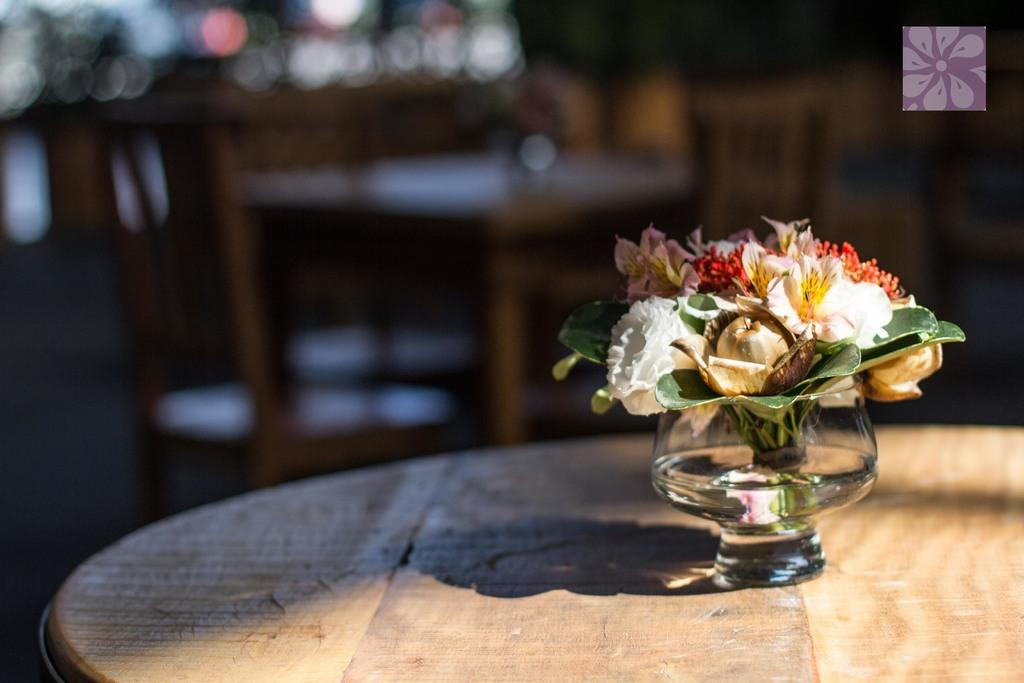What is the main object in the image? There is a table in the image. What is placed on the table? There are flowers on the table. How are the flowers arranged or contained? The flowers are kept in a glass. Can you describe the background of the image? The background of the image is blurry. What is the temper of the cannon in the image? There is no cannon present in the image, so it is not possible to determine its temper. 